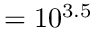Convert formula to latex. <formula><loc_0><loc_0><loc_500><loc_500>= 1 0 ^ { 3 . 5 }</formula> 